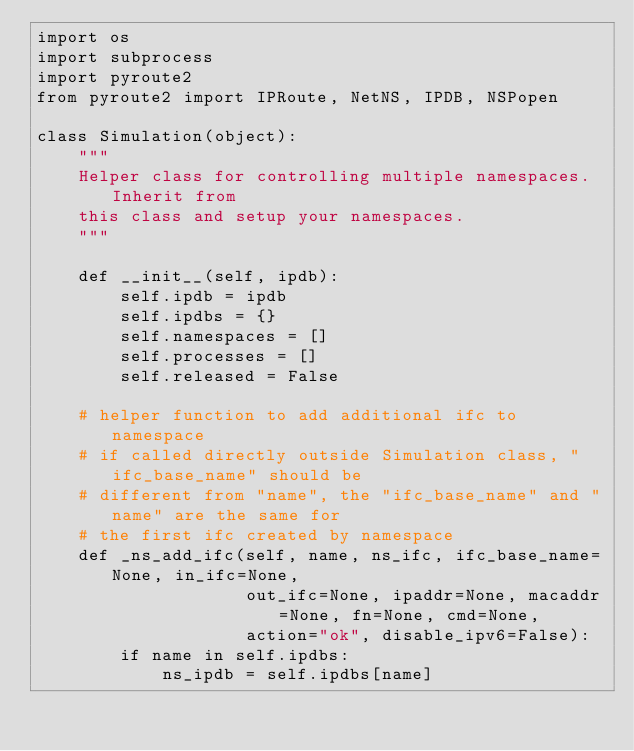<code> <loc_0><loc_0><loc_500><loc_500><_Python_>import os
import subprocess
import pyroute2
from pyroute2 import IPRoute, NetNS, IPDB, NSPopen

class Simulation(object):
    """
    Helper class for controlling multiple namespaces. Inherit from
    this class and setup your namespaces.
    """

    def __init__(self, ipdb):
        self.ipdb = ipdb
        self.ipdbs = {}
        self.namespaces = []
        self.processes = []
        self.released = False

    # helper function to add additional ifc to namespace
    # if called directly outside Simulation class, "ifc_base_name" should be
    # different from "name", the "ifc_base_name" and "name" are the same for
    # the first ifc created by namespace
    def _ns_add_ifc(self, name, ns_ifc, ifc_base_name=None, in_ifc=None,
                    out_ifc=None, ipaddr=None, macaddr=None, fn=None, cmd=None,
                    action="ok", disable_ipv6=False):
        if name in self.ipdbs:
            ns_ipdb = self.ipdbs[name]</code> 